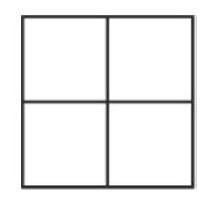The numbers $1,2,3$ and 4 are inserted into different cells of the $2 \times 2$ table shown. Then the sums of the numbers in each row and column are determined. Two of these sums are 4 and 5. How big are the two remaining sums? To solve the puzzle, we must place the numbers 1, 2, 3, and 4 into the cells of a 2x2 table in such a way that two of the sums of each row and column equal 4 and 5. The only way to achieve this is by placing 1 and 3 in one row or column, and 2 and 4 in another, since 1+3=4 and 2+4=6. Thus, if the sums of two row/column pairs are 4 and 5, the remaining sums must be 3 (1+2) and 6 (3+4) respectively. Therefore, the two remaining sums are 3 and 6, and the correct choice is '3 and 6'. 